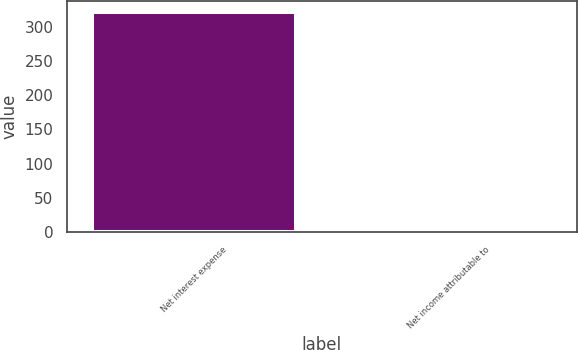Convert chart to OTSL. <chart><loc_0><loc_0><loc_500><loc_500><bar_chart><fcel>Net interest expense<fcel>Net income attributable to<nl><fcel>321<fcel>6<nl></chart> 